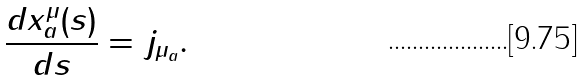<formula> <loc_0><loc_0><loc_500><loc_500>\frac { d x _ { a } ^ { \mu } ( s ) } { d s } = j _ { \mu _ { a } } .</formula> 